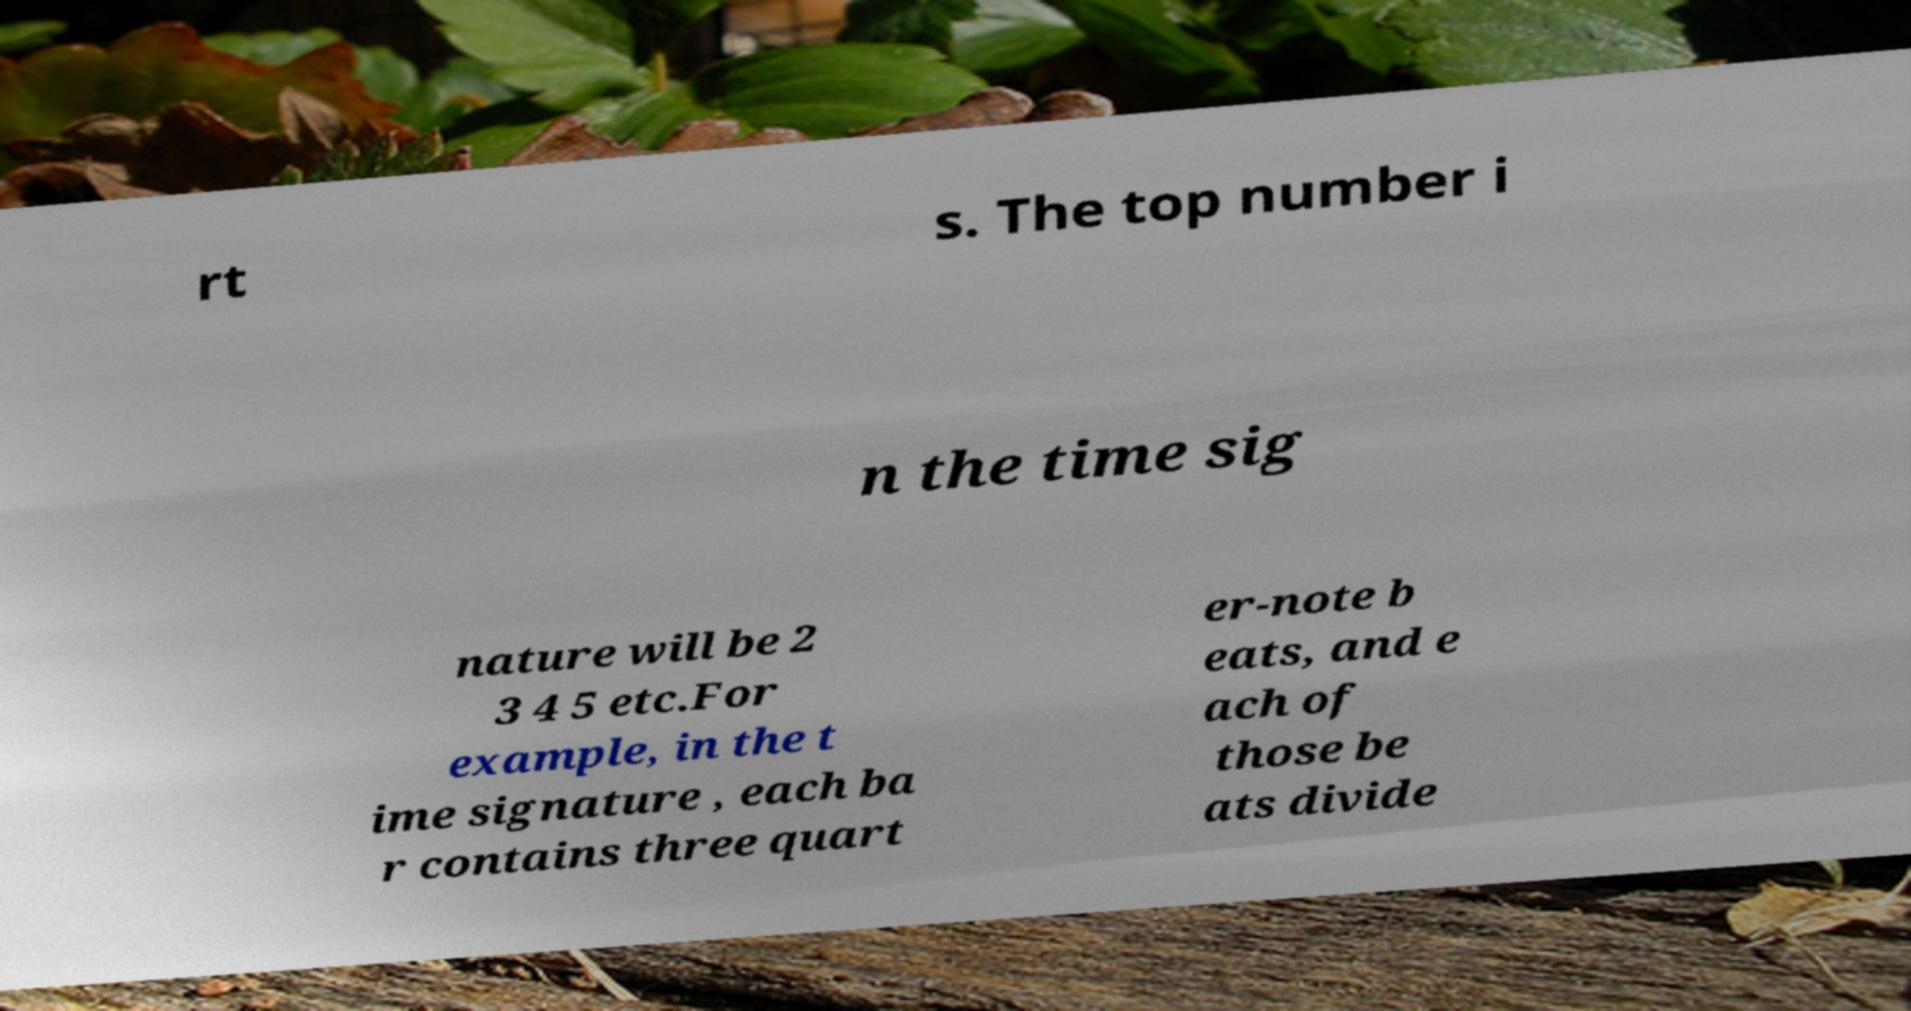There's text embedded in this image that I need extracted. Can you transcribe it verbatim? rt s. The top number i n the time sig nature will be 2 3 4 5 etc.For example, in the t ime signature , each ba r contains three quart er-note b eats, and e ach of those be ats divide 